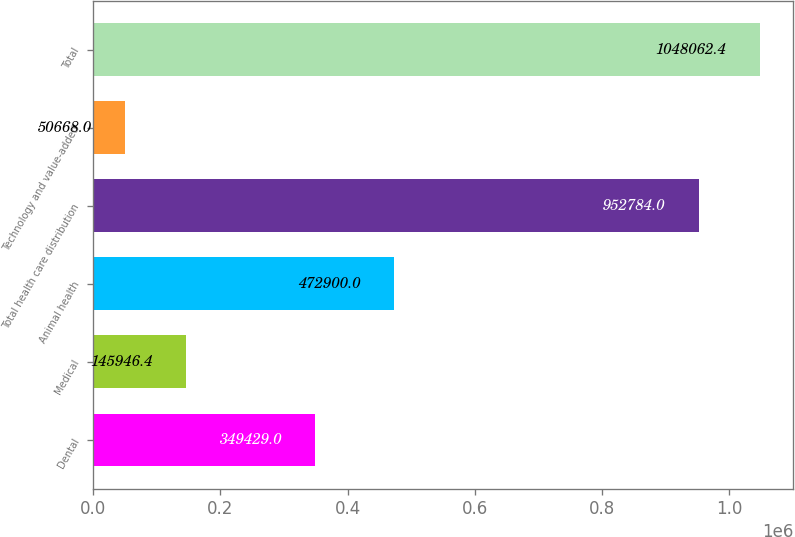<chart> <loc_0><loc_0><loc_500><loc_500><bar_chart><fcel>Dental<fcel>Medical<fcel>Animal health<fcel>Total health care distribution<fcel>Technology and value-added<fcel>Total<nl><fcel>349429<fcel>145946<fcel>472900<fcel>952784<fcel>50668<fcel>1.04806e+06<nl></chart> 